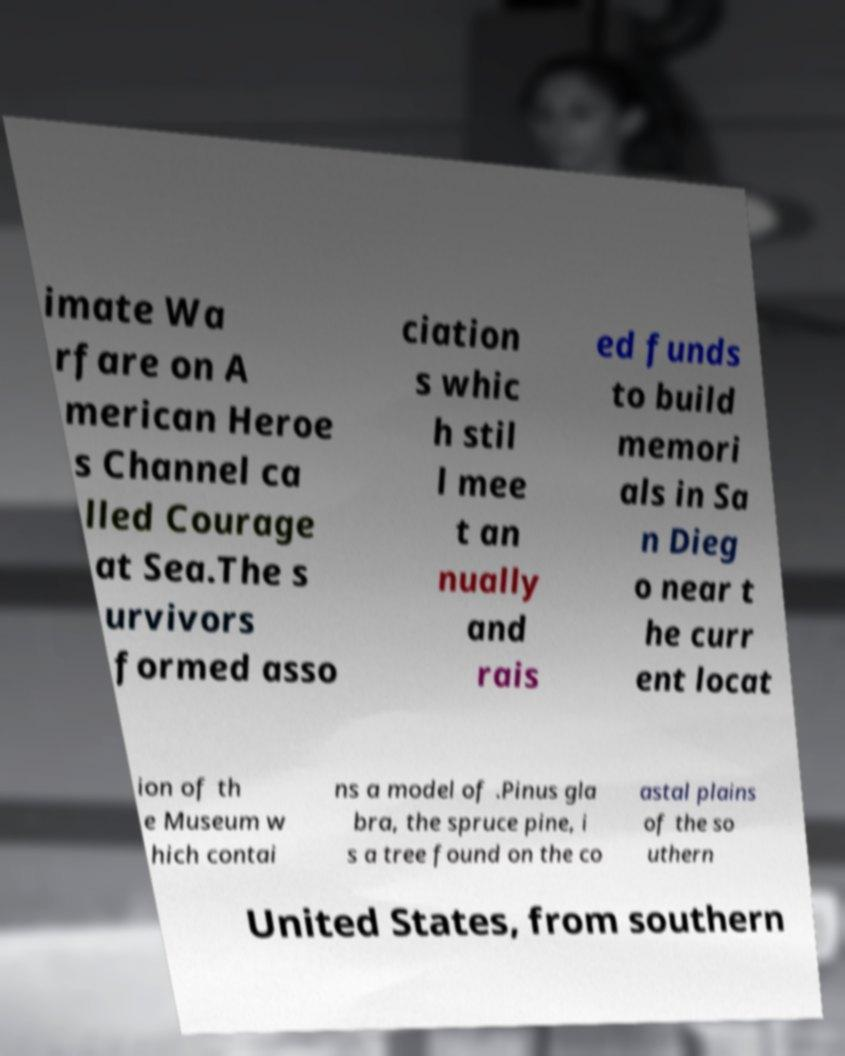Please identify and transcribe the text found in this image. imate Wa rfare on A merican Heroe s Channel ca lled Courage at Sea.The s urvivors formed asso ciation s whic h stil l mee t an nually and rais ed funds to build memori als in Sa n Dieg o near t he curr ent locat ion of th e Museum w hich contai ns a model of .Pinus gla bra, the spruce pine, i s a tree found on the co astal plains of the so uthern United States, from southern 